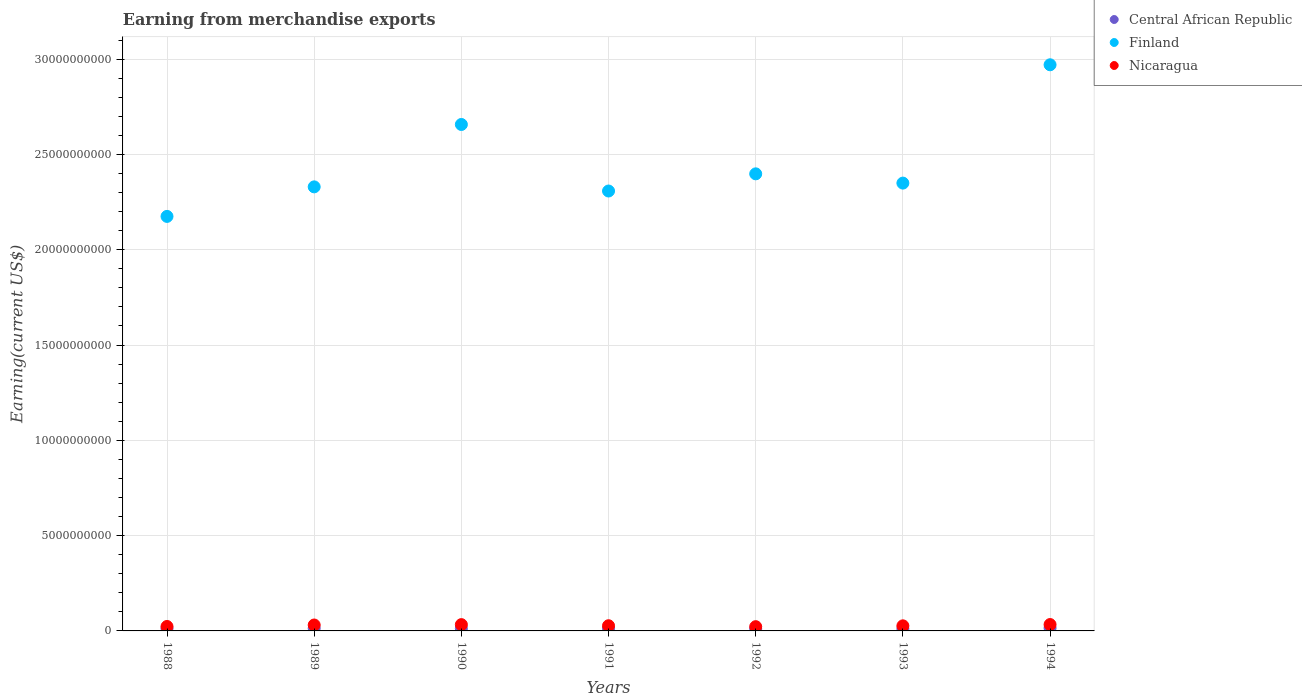How many different coloured dotlines are there?
Your response must be concise. 3. Is the number of dotlines equal to the number of legend labels?
Ensure brevity in your answer.  Yes. What is the amount earned from merchandise exports in Finland in 1988?
Ensure brevity in your answer.  2.17e+1. Across all years, what is the maximum amount earned from merchandise exports in Nicaragua?
Your answer should be very brief. 3.35e+08. Across all years, what is the minimum amount earned from merchandise exports in Central African Republic?
Your response must be concise. 1.07e+08. In which year was the amount earned from merchandise exports in Central African Republic maximum?
Provide a short and direct response. 1994. What is the total amount earned from merchandise exports in Nicaragua in the graph?
Give a very brief answer. 1.97e+09. What is the difference between the amount earned from merchandise exports in Nicaragua in 1988 and that in 1992?
Give a very brief answer. 1.00e+07. What is the difference between the amount earned from merchandise exports in Nicaragua in 1993 and the amount earned from merchandise exports in Finland in 1988?
Offer a very short reply. -2.15e+1. What is the average amount earned from merchandise exports in Central African Republic per year?
Your response must be concise. 1.25e+08. In the year 1993, what is the difference between the amount earned from merchandise exports in Central African Republic and amount earned from merchandise exports in Finland?
Ensure brevity in your answer.  -2.34e+1. What is the ratio of the amount earned from merchandise exports in Nicaragua in 1993 to that in 1994?
Your response must be concise. 0.8. What is the difference between the highest and the second highest amount earned from merchandise exports in Finland?
Provide a short and direct response. 3.13e+09. What is the difference between the highest and the lowest amount earned from merchandise exports in Nicaragua?
Ensure brevity in your answer.  1.12e+08. Is the sum of the amount earned from merchandise exports in Central African Republic in 1988 and 1989 greater than the maximum amount earned from merchandise exports in Finland across all years?
Your answer should be compact. No. Is it the case that in every year, the sum of the amount earned from merchandise exports in Finland and amount earned from merchandise exports in Central African Republic  is greater than the amount earned from merchandise exports in Nicaragua?
Your answer should be compact. Yes. Is the amount earned from merchandise exports in Central African Republic strictly greater than the amount earned from merchandise exports in Nicaragua over the years?
Offer a very short reply. No. How many dotlines are there?
Keep it short and to the point. 3. Does the graph contain any zero values?
Give a very brief answer. No. How many legend labels are there?
Ensure brevity in your answer.  3. What is the title of the graph?
Your answer should be very brief. Earning from merchandise exports. What is the label or title of the Y-axis?
Keep it short and to the point. Earning(current US$). What is the Earning(current US$) of Central African Republic in 1988?
Offer a very short reply. 1.30e+08. What is the Earning(current US$) of Finland in 1988?
Provide a succinct answer. 2.17e+1. What is the Earning(current US$) of Nicaragua in 1988?
Your answer should be compact. 2.33e+08. What is the Earning(current US$) of Central African Republic in 1989?
Ensure brevity in your answer.  1.34e+08. What is the Earning(current US$) of Finland in 1989?
Offer a very short reply. 2.33e+1. What is the Earning(current US$) in Nicaragua in 1989?
Your answer should be very brief. 3.11e+08. What is the Earning(current US$) in Central African Republic in 1990?
Your answer should be very brief. 1.20e+08. What is the Earning(current US$) in Finland in 1990?
Provide a succinct answer. 2.66e+1. What is the Earning(current US$) of Nicaragua in 1990?
Ensure brevity in your answer.  3.30e+08. What is the Earning(current US$) in Central African Republic in 1991?
Keep it short and to the point. 1.26e+08. What is the Earning(current US$) in Finland in 1991?
Keep it short and to the point. 2.31e+1. What is the Earning(current US$) of Nicaragua in 1991?
Your response must be concise. 2.72e+08. What is the Earning(current US$) of Central African Republic in 1992?
Provide a short and direct response. 1.07e+08. What is the Earning(current US$) of Finland in 1992?
Make the answer very short. 2.40e+1. What is the Earning(current US$) of Nicaragua in 1992?
Keep it short and to the point. 2.23e+08. What is the Earning(current US$) of Central African Republic in 1993?
Provide a succinct answer. 1.10e+08. What is the Earning(current US$) in Finland in 1993?
Make the answer very short. 2.35e+1. What is the Earning(current US$) of Nicaragua in 1993?
Your answer should be compact. 2.67e+08. What is the Earning(current US$) in Central African Republic in 1994?
Your response must be concise. 1.51e+08. What is the Earning(current US$) in Finland in 1994?
Ensure brevity in your answer.  2.97e+1. What is the Earning(current US$) in Nicaragua in 1994?
Your answer should be compact. 3.35e+08. Across all years, what is the maximum Earning(current US$) of Central African Republic?
Provide a short and direct response. 1.51e+08. Across all years, what is the maximum Earning(current US$) of Finland?
Your answer should be compact. 2.97e+1. Across all years, what is the maximum Earning(current US$) of Nicaragua?
Provide a short and direct response. 3.35e+08. Across all years, what is the minimum Earning(current US$) of Central African Republic?
Your answer should be compact. 1.07e+08. Across all years, what is the minimum Earning(current US$) of Finland?
Ensure brevity in your answer.  2.17e+1. Across all years, what is the minimum Earning(current US$) in Nicaragua?
Your response must be concise. 2.23e+08. What is the total Earning(current US$) of Central African Republic in the graph?
Ensure brevity in your answer.  8.78e+08. What is the total Earning(current US$) of Finland in the graph?
Your answer should be very brief. 1.72e+11. What is the total Earning(current US$) in Nicaragua in the graph?
Keep it short and to the point. 1.97e+09. What is the difference between the Earning(current US$) in Central African Republic in 1988 and that in 1989?
Offer a terse response. -4.00e+06. What is the difference between the Earning(current US$) in Finland in 1988 and that in 1989?
Offer a very short reply. -1.55e+09. What is the difference between the Earning(current US$) of Nicaragua in 1988 and that in 1989?
Make the answer very short. -7.80e+07. What is the difference between the Earning(current US$) of Central African Republic in 1988 and that in 1990?
Provide a short and direct response. 1.00e+07. What is the difference between the Earning(current US$) in Finland in 1988 and that in 1990?
Ensure brevity in your answer.  -4.82e+09. What is the difference between the Earning(current US$) of Nicaragua in 1988 and that in 1990?
Ensure brevity in your answer.  -9.70e+07. What is the difference between the Earning(current US$) in Central African Republic in 1988 and that in 1991?
Make the answer very short. 4.00e+06. What is the difference between the Earning(current US$) in Finland in 1988 and that in 1991?
Your answer should be compact. -1.33e+09. What is the difference between the Earning(current US$) of Nicaragua in 1988 and that in 1991?
Ensure brevity in your answer.  -3.90e+07. What is the difference between the Earning(current US$) of Central African Republic in 1988 and that in 1992?
Provide a short and direct response. 2.30e+07. What is the difference between the Earning(current US$) of Finland in 1988 and that in 1992?
Offer a terse response. -2.23e+09. What is the difference between the Earning(current US$) in Finland in 1988 and that in 1993?
Provide a short and direct response. -1.75e+09. What is the difference between the Earning(current US$) in Nicaragua in 1988 and that in 1993?
Provide a short and direct response. -3.40e+07. What is the difference between the Earning(current US$) in Central African Republic in 1988 and that in 1994?
Your answer should be compact. -2.10e+07. What is the difference between the Earning(current US$) of Finland in 1988 and that in 1994?
Ensure brevity in your answer.  -7.96e+09. What is the difference between the Earning(current US$) of Nicaragua in 1988 and that in 1994?
Offer a very short reply. -1.02e+08. What is the difference between the Earning(current US$) of Central African Republic in 1989 and that in 1990?
Your answer should be compact. 1.40e+07. What is the difference between the Earning(current US$) of Finland in 1989 and that in 1990?
Your answer should be very brief. -3.27e+09. What is the difference between the Earning(current US$) in Nicaragua in 1989 and that in 1990?
Offer a terse response. -1.90e+07. What is the difference between the Earning(current US$) of Central African Republic in 1989 and that in 1991?
Your answer should be compact. 8.00e+06. What is the difference between the Earning(current US$) of Finland in 1989 and that in 1991?
Your response must be concise. 2.18e+08. What is the difference between the Earning(current US$) of Nicaragua in 1989 and that in 1991?
Ensure brevity in your answer.  3.90e+07. What is the difference between the Earning(current US$) of Central African Republic in 1989 and that in 1992?
Provide a succinct answer. 2.70e+07. What is the difference between the Earning(current US$) in Finland in 1989 and that in 1992?
Your answer should be very brief. -6.83e+08. What is the difference between the Earning(current US$) of Nicaragua in 1989 and that in 1992?
Your answer should be very brief. 8.80e+07. What is the difference between the Earning(current US$) in Central African Republic in 1989 and that in 1993?
Ensure brevity in your answer.  2.40e+07. What is the difference between the Earning(current US$) in Finland in 1989 and that in 1993?
Your answer should be very brief. -1.97e+08. What is the difference between the Earning(current US$) of Nicaragua in 1989 and that in 1993?
Provide a short and direct response. 4.40e+07. What is the difference between the Earning(current US$) in Central African Republic in 1989 and that in 1994?
Your answer should be very brief. -1.70e+07. What is the difference between the Earning(current US$) in Finland in 1989 and that in 1994?
Give a very brief answer. -6.40e+09. What is the difference between the Earning(current US$) of Nicaragua in 1989 and that in 1994?
Provide a short and direct response. -2.37e+07. What is the difference between the Earning(current US$) of Central African Republic in 1990 and that in 1991?
Offer a terse response. -6.00e+06. What is the difference between the Earning(current US$) in Finland in 1990 and that in 1991?
Your answer should be very brief. 3.49e+09. What is the difference between the Earning(current US$) of Nicaragua in 1990 and that in 1991?
Provide a succinct answer. 5.80e+07. What is the difference between the Earning(current US$) of Central African Republic in 1990 and that in 1992?
Give a very brief answer. 1.30e+07. What is the difference between the Earning(current US$) of Finland in 1990 and that in 1992?
Your answer should be compact. 2.59e+09. What is the difference between the Earning(current US$) of Nicaragua in 1990 and that in 1992?
Make the answer very short. 1.07e+08. What is the difference between the Earning(current US$) in Finland in 1990 and that in 1993?
Make the answer very short. 3.08e+09. What is the difference between the Earning(current US$) of Nicaragua in 1990 and that in 1993?
Offer a very short reply. 6.30e+07. What is the difference between the Earning(current US$) in Central African Republic in 1990 and that in 1994?
Your response must be concise. -3.10e+07. What is the difference between the Earning(current US$) of Finland in 1990 and that in 1994?
Your answer should be compact. -3.13e+09. What is the difference between the Earning(current US$) of Nicaragua in 1990 and that in 1994?
Ensure brevity in your answer.  -4.70e+06. What is the difference between the Earning(current US$) in Central African Republic in 1991 and that in 1992?
Offer a terse response. 1.90e+07. What is the difference between the Earning(current US$) in Finland in 1991 and that in 1992?
Keep it short and to the point. -9.01e+08. What is the difference between the Earning(current US$) of Nicaragua in 1991 and that in 1992?
Ensure brevity in your answer.  4.90e+07. What is the difference between the Earning(current US$) of Central African Republic in 1991 and that in 1993?
Offer a very short reply. 1.60e+07. What is the difference between the Earning(current US$) in Finland in 1991 and that in 1993?
Offer a terse response. -4.15e+08. What is the difference between the Earning(current US$) of Central African Republic in 1991 and that in 1994?
Keep it short and to the point. -2.50e+07. What is the difference between the Earning(current US$) in Finland in 1991 and that in 1994?
Your response must be concise. -6.62e+09. What is the difference between the Earning(current US$) in Nicaragua in 1991 and that in 1994?
Provide a short and direct response. -6.27e+07. What is the difference between the Earning(current US$) in Central African Republic in 1992 and that in 1993?
Offer a very short reply. -3.00e+06. What is the difference between the Earning(current US$) of Finland in 1992 and that in 1993?
Keep it short and to the point. 4.86e+08. What is the difference between the Earning(current US$) in Nicaragua in 1992 and that in 1993?
Offer a terse response. -4.40e+07. What is the difference between the Earning(current US$) of Central African Republic in 1992 and that in 1994?
Make the answer very short. -4.40e+07. What is the difference between the Earning(current US$) of Finland in 1992 and that in 1994?
Keep it short and to the point. -5.72e+09. What is the difference between the Earning(current US$) in Nicaragua in 1992 and that in 1994?
Your answer should be compact. -1.12e+08. What is the difference between the Earning(current US$) of Central African Republic in 1993 and that in 1994?
Provide a short and direct response. -4.10e+07. What is the difference between the Earning(current US$) of Finland in 1993 and that in 1994?
Ensure brevity in your answer.  -6.21e+09. What is the difference between the Earning(current US$) in Nicaragua in 1993 and that in 1994?
Offer a very short reply. -6.77e+07. What is the difference between the Earning(current US$) of Central African Republic in 1988 and the Earning(current US$) of Finland in 1989?
Make the answer very short. -2.32e+1. What is the difference between the Earning(current US$) in Central African Republic in 1988 and the Earning(current US$) in Nicaragua in 1989?
Provide a succinct answer. -1.81e+08. What is the difference between the Earning(current US$) in Finland in 1988 and the Earning(current US$) in Nicaragua in 1989?
Your response must be concise. 2.14e+1. What is the difference between the Earning(current US$) in Central African Republic in 1988 and the Earning(current US$) in Finland in 1990?
Offer a very short reply. -2.64e+1. What is the difference between the Earning(current US$) in Central African Republic in 1988 and the Earning(current US$) in Nicaragua in 1990?
Offer a very short reply. -2.00e+08. What is the difference between the Earning(current US$) of Finland in 1988 and the Earning(current US$) of Nicaragua in 1990?
Offer a terse response. 2.14e+1. What is the difference between the Earning(current US$) in Central African Republic in 1988 and the Earning(current US$) in Finland in 1991?
Your answer should be compact. -2.30e+1. What is the difference between the Earning(current US$) of Central African Republic in 1988 and the Earning(current US$) of Nicaragua in 1991?
Ensure brevity in your answer.  -1.42e+08. What is the difference between the Earning(current US$) in Finland in 1988 and the Earning(current US$) in Nicaragua in 1991?
Provide a short and direct response. 2.15e+1. What is the difference between the Earning(current US$) in Central African Republic in 1988 and the Earning(current US$) in Finland in 1992?
Your response must be concise. -2.39e+1. What is the difference between the Earning(current US$) of Central African Republic in 1988 and the Earning(current US$) of Nicaragua in 1992?
Keep it short and to the point. -9.30e+07. What is the difference between the Earning(current US$) in Finland in 1988 and the Earning(current US$) in Nicaragua in 1992?
Ensure brevity in your answer.  2.15e+1. What is the difference between the Earning(current US$) of Central African Republic in 1988 and the Earning(current US$) of Finland in 1993?
Your answer should be compact. -2.34e+1. What is the difference between the Earning(current US$) in Central African Republic in 1988 and the Earning(current US$) in Nicaragua in 1993?
Offer a very short reply. -1.37e+08. What is the difference between the Earning(current US$) of Finland in 1988 and the Earning(current US$) of Nicaragua in 1993?
Make the answer very short. 2.15e+1. What is the difference between the Earning(current US$) in Central African Republic in 1988 and the Earning(current US$) in Finland in 1994?
Ensure brevity in your answer.  -2.96e+1. What is the difference between the Earning(current US$) in Central African Republic in 1988 and the Earning(current US$) in Nicaragua in 1994?
Offer a very short reply. -2.05e+08. What is the difference between the Earning(current US$) of Finland in 1988 and the Earning(current US$) of Nicaragua in 1994?
Ensure brevity in your answer.  2.14e+1. What is the difference between the Earning(current US$) in Central African Republic in 1989 and the Earning(current US$) in Finland in 1990?
Provide a short and direct response. -2.64e+1. What is the difference between the Earning(current US$) in Central African Republic in 1989 and the Earning(current US$) in Nicaragua in 1990?
Offer a terse response. -1.96e+08. What is the difference between the Earning(current US$) of Finland in 1989 and the Earning(current US$) of Nicaragua in 1990?
Your answer should be very brief. 2.30e+1. What is the difference between the Earning(current US$) in Central African Republic in 1989 and the Earning(current US$) in Finland in 1991?
Your answer should be very brief. -2.29e+1. What is the difference between the Earning(current US$) of Central African Republic in 1989 and the Earning(current US$) of Nicaragua in 1991?
Offer a terse response. -1.38e+08. What is the difference between the Earning(current US$) of Finland in 1989 and the Earning(current US$) of Nicaragua in 1991?
Your answer should be very brief. 2.30e+1. What is the difference between the Earning(current US$) of Central African Republic in 1989 and the Earning(current US$) of Finland in 1992?
Give a very brief answer. -2.38e+1. What is the difference between the Earning(current US$) of Central African Republic in 1989 and the Earning(current US$) of Nicaragua in 1992?
Provide a short and direct response. -8.90e+07. What is the difference between the Earning(current US$) of Finland in 1989 and the Earning(current US$) of Nicaragua in 1992?
Make the answer very short. 2.31e+1. What is the difference between the Earning(current US$) of Central African Republic in 1989 and the Earning(current US$) of Finland in 1993?
Provide a short and direct response. -2.34e+1. What is the difference between the Earning(current US$) of Central African Republic in 1989 and the Earning(current US$) of Nicaragua in 1993?
Ensure brevity in your answer.  -1.33e+08. What is the difference between the Earning(current US$) of Finland in 1989 and the Earning(current US$) of Nicaragua in 1993?
Give a very brief answer. 2.30e+1. What is the difference between the Earning(current US$) of Central African Republic in 1989 and the Earning(current US$) of Finland in 1994?
Your answer should be very brief. -2.96e+1. What is the difference between the Earning(current US$) in Central African Republic in 1989 and the Earning(current US$) in Nicaragua in 1994?
Your answer should be compact. -2.01e+08. What is the difference between the Earning(current US$) of Finland in 1989 and the Earning(current US$) of Nicaragua in 1994?
Offer a terse response. 2.30e+1. What is the difference between the Earning(current US$) in Central African Republic in 1990 and the Earning(current US$) in Finland in 1991?
Provide a succinct answer. -2.30e+1. What is the difference between the Earning(current US$) in Central African Republic in 1990 and the Earning(current US$) in Nicaragua in 1991?
Your answer should be compact. -1.52e+08. What is the difference between the Earning(current US$) of Finland in 1990 and the Earning(current US$) of Nicaragua in 1991?
Ensure brevity in your answer.  2.63e+1. What is the difference between the Earning(current US$) in Central African Republic in 1990 and the Earning(current US$) in Finland in 1992?
Keep it short and to the point. -2.39e+1. What is the difference between the Earning(current US$) in Central African Republic in 1990 and the Earning(current US$) in Nicaragua in 1992?
Offer a terse response. -1.03e+08. What is the difference between the Earning(current US$) in Finland in 1990 and the Earning(current US$) in Nicaragua in 1992?
Offer a very short reply. 2.63e+1. What is the difference between the Earning(current US$) of Central African Republic in 1990 and the Earning(current US$) of Finland in 1993?
Your answer should be very brief. -2.34e+1. What is the difference between the Earning(current US$) in Central African Republic in 1990 and the Earning(current US$) in Nicaragua in 1993?
Your answer should be very brief. -1.47e+08. What is the difference between the Earning(current US$) of Finland in 1990 and the Earning(current US$) of Nicaragua in 1993?
Keep it short and to the point. 2.63e+1. What is the difference between the Earning(current US$) of Central African Republic in 1990 and the Earning(current US$) of Finland in 1994?
Ensure brevity in your answer.  -2.96e+1. What is the difference between the Earning(current US$) in Central African Republic in 1990 and the Earning(current US$) in Nicaragua in 1994?
Offer a terse response. -2.15e+08. What is the difference between the Earning(current US$) of Finland in 1990 and the Earning(current US$) of Nicaragua in 1994?
Give a very brief answer. 2.62e+1. What is the difference between the Earning(current US$) of Central African Republic in 1991 and the Earning(current US$) of Finland in 1992?
Provide a succinct answer. -2.39e+1. What is the difference between the Earning(current US$) in Central African Republic in 1991 and the Earning(current US$) in Nicaragua in 1992?
Provide a short and direct response. -9.70e+07. What is the difference between the Earning(current US$) of Finland in 1991 and the Earning(current US$) of Nicaragua in 1992?
Make the answer very short. 2.29e+1. What is the difference between the Earning(current US$) of Central African Republic in 1991 and the Earning(current US$) of Finland in 1993?
Provide a succinct answer. -2.34e+1. What is the difference between the Earning(current US$) in Central African Republic in 1991 and the Earning(current US$) in Nicaragua in 1993?
Ensure brevity in your answer.  -1.41e+08. What is the difference between the Earning(current US$) in Finland in 1991 and the Earning(current US$) in Nicaragua in 1993?
Provide a succinct answer. 2.28e+1. What is the difference between the Earning(current US$) of Central African Republic in 1991 and the Earning(current US$) of Finland in 1994?
Give a very brief answer. -2.96e+1. What is the difference between the Earning(current US$) of Central African Republic in 1991 and the Earning(current US$) of Nicaragua in 1994?
Your response must be concise. -2.09e+08. What is the difference between the Earning(current US$) of Finland in 1991 and the Earning(current US$) of Nicaragua in 1994?
Your answer should be very brief. 2.27e+1. What is the difference between the Earning(current US$) of Central African Republic in 1992 and the Earning(current US$) of Finland in 1993?
Ensure brevity in your answer.  -2.34e+1. What is the difference between the Earning(current US$) in Central African Republic in 1992 and the Earning(current US$) in Nicaragua in 1993?
Keep it short and to the point. -1.60e+08. What is the difference between the Earning(current US$) in Finland in 1992 and the Earning(current US$) in Nicaragua in 1993?
Keep it short and to the point. 2.37e+1. What is the difference between the Earning(current US$) of Central African Republic in 1992 and the Earning(current US$) of Finland in 1994?
Your response must be concise. -2.96e+1. What is the difference between the Earning(current US$) of Central African Republic in 1992 and the Earning(current US$) of Nicaragua in 1994?
Offer a terse response. -2.28e+08. What is the difference between the Earning(current US$) of Finland in 1992 and the Earning(current US$) of Nicaragua in 1994?
Offer a terse response. 2.36e+1. What is the difference between the Earning(current US$) in Central African Republic in 1993 and the Earning(current US$) in Finland in 1994?
Make the answer very short. -2.96e+1. What is the difference between the Earning(current US$) in Central African Republic in 1993 and the Earning(current US$) in Nicaragua in 1994?
Provide a short and direct response. -2.25e+08. What is the difference between the Earning(current US$) in Finland in 1993 and the Earning(current US$) in Nicaragua in 1994?
Offer a terse response. 2.32e+1. What is the average Earning(current US$) in Central African Republic per year?
Your answer should be compact. 1.25e+08. What is the average Earning(current US$) in Finland per year?
Your response must be concise. 2.46e+1. What is the average Earning(current US$) in Nicaragua per year?
Offer a very short reply. 2.82e+08. In the year 1988, what is the difference between the Earning(current US$) of Central African Republic and Earning(current US$) of Finland?
Your response must be concise. -2.16e+1. In the year 1988, what is the difference between the Earning(current US$) in Central African Republic and Earning(current US$) in Nicaragua?
Offer a very short reply. -1.03e+08. In the year 1988, what is the difference between the Earning(current US$) of Finland and Earning(current US$) of Nicaragua?
Your response must be concise. 2.15e+1. In the year 1989, what is the difference between the Earning(current US$) in Central African Republic and Earning(current US$) in Finland?
Offer a very short reply. -2.32e+1. In the year 1989, what is the difference between the Earning(current US$) of Central African Republic and Earning(current US$) of Nicaragua?
Provide a succinct answer. -1.77e+08. In the year 1989, what is the difference between the Earning(current US$) in Finland and Earning(current US$) in Nicaragua?
Offer a very short reply. 2.30e+1. In the year 1990, what is the difference between the Earning(current US$) in Central African Republic and Earning(current US$) in Finland?
Ensure brevity in your answer.  -2.65e+1. In the year 1990, what is the difference between the Earning(current US$) of Central African Republic and Earning(current US$) of Nicaragua?
Provide a succinct answer. -2.10e+08. In the year 1990, what is the difference between the Earning(current US$) of Finland and Earning(current US$) of Nicaragua?
Give a very brief answer. 2.62e+1. In the year 1991, what is the difference between the Earning(current US$) in Central African Republic and Earning(current US$) in Finland?
Your response must be concise. -2.30e+1. In the year 1991, what is the difference between the Earning(current US$) in Central African Republic and Earning(current US$) in Nicaragua?
Your answer should be compact. -1.46e+08. In the year 1991, what is the difference between the Earning(current US$) of Finland and Earning(current US$) of Nicaragua?
Your answer should be very brief. 2.28e+1. In the year 1992, what is the difference between the Earning(current US$) of Central African Republic and Earning(current US$) of Finland?
Your response must be concise. -2.39e+1. In the year 1992, what is the difference between the Earning(current US$) in Central African Republic and Earning(current US$) in Nicaragua?
Your answer should be very brief. -1.16e+08. In the year 1992, what is the difference between the Earning(current US$) of Finland and Earning(current US$) of Nicaragua?
Your answer should be very brief. 2.38e+1. In the year 1993, what is the difference between the Earning(current US$) in Central African Republic and Earning(current US$) in Finland?
Ensure brevity in your answer.  -2.34e+1. In the year 1993, what is the difference between the Earning(current US$) in Central African Republic and Earning(current US$) in Nicaragua?
Offer a terse response. -1.57e+08. In the year 1993, what is the difference between the Earning(current US$) of Finland and Earning(current US$) of Nicaragua?
Give a very brief answer. 2.32e+1. In the year 1994, what is the difference between the Earning(current US$) of Central African Republic and Earning(current US$) of Finland?
Make the answer very short. -2.96e+1. In the year 1994, what is the difference between the Earning(current US$) in Central African Republic and Earning(current US$) in Nicaragua?
Your answer should be very brief. -1.84e+08. In the year 1994, what is the difference between the Earning(current US$) in Finland and Earning(current US$) in Nicaragua?
Ensure brevity in your answer.  2.94e+1. What is the ratio of the Earning(current US$) in Central African Republic in 1988 to that in 1989?
Your answer should be very brief. 0.97. What is the ratio of the Earning(current US$) of Finland in 1988 to that in 1989?
Offer a terse response. 0.93. What is the ratio of the Earning(current US$) in Nicaragua in 1988 to that in 1989?
Ensure brevity in your answer.  0.75. What is the ratio of the Earning(current US$) in Finland in 1988 to that in 1990?
Keep it short and to the point. 0.82. What is the ratio of the Earning(current US$) in Nicaragua in 1988 to that in 1990?
Ensure brevity in your answer.  0.71. What is the ratio of the Earning(current US$) in Central African Republic in 1988 to that in 1991?
Offer a terse response. 1.03. What is the ratio of the Earning(current US$) of Finland in 1988 to that in 1991?
Give a very brief answer. 0.94. What is the ratio of the Earning(current US$) of Nicaragua in 1988 to that in 1991?
Your answer should be compact. 0.86. What is the ratio of the Earning(current US$) in Central African Republic in 1988 to that in 1992?
Give a very brief answer. 1.22. What is the ratio of the Earning(current US$) in Finland in 1988 to that in 1992?
Ensure brevity in your answer.  0.91. What is the ratio of the Earning(current US$) in Nicaragua in 1988 to that in 1992?
Ensure brevity in your answer.  1.04. What is the ratio of the Earning(current US$) of Central African Republic in 1988 to that in 1993?
Provide a short and direct response. 1.18. What is the ratio of the Earning(current US$) of Finland in 1988 to that in 1993?
Offer a very short reply. 0.93. What is the ratio of the Earning(current US$) of Nicaragua in 1988 to that in 1993?
Give a very brief answer. 0.87. What is the ratio of the Earning(current US$) of Central African Republic in 1988 to that in 1994?
Provide a succinct answer. 0.86. What is the ratio of the Earning(current US$) of Finland in 1988 to that in 1994?
Ensure brevity in your answer.  0.73. What is the ratio of the Earning(current US$) of Nicaragua in 1988 to that in 1994?
Your response must be concise. 0.7. What is the ratio of the Earning(current US$) of Central African Republic in 1989 to that in 1990?
Your answer should be very brief. 1.12. What is the ratio of the Earning(current US$) of Finland in 1989 to that in 1990?
Offer a very short reply. 0.88. What is the ratio of the Earning(current US$) of Nicaragua in 1989 to that in 1990?
Ensure brevity in your answer.  0.94. What is the ratio of the Earning(current US$) in Central African Republic in 1989 to that in 1991?
Make the answer very short. 1.06. What is the ratio of the Earning(current US$) in Finland in 1989 to that in 1991?
Your answer should be very brief. 1.01. What is the ratio of the Earning(current US$) of Nicaragua in 1989 to that in 1991?
Provide a succinct answer. 1.14. What is the ratio of the Earning(current US$) in Central African Republic in 1989 to that in 1992?
Your response must be concise. 1.25. What is the ratio of the Earning(current US$) in Finland in 1989 to that in 1992?
Keep it short and to the point. 0.97. What is the ratio of the Earning(current US$) of Nicaragua in 1989 to that in 1992?
Offer a terse response. 1.39. What is the ratio of the Earning(current US$) of Central African Republic in 1989 to that in 1993?
Give a very brief answer. 1.22. What is the ratio of the Earning(current US$) of Nicaragua in 1989 to that in 1993?
Offer a very short reply. 1.16. What is the ratio of the Earning(current US$) of Central African Republic in 1989 to that in 1994?
Provide a short and direct response. 0.89. What is the ratio of the Earning(current US$) in Finland in 1989 to that in 1994?
Provide a succinct answer. 0.78. What is the ratio of the Earning(current US$) in Nicaragua in 1989 to that in 1994?
Provide a short and direct response. 0.93. What is the ratio of the Earning(current US$) of Finland in 1990 to that in 1991?
Make the answer very short. 1.15. What is the ratio of the Earning(current US$) in Nicaragua in 1990 to that in 1991?
Ensure brevity in your answer.  1.21. What is the ratio of the Earning(current US$) in Central African Republic in 1990 to that in 1992?
Offer a very short reply. 1.12. What is the ratio of the Earning(current US$) in Finland in 1990 to that in 1992?
Give a very brief answer. 1.11. What is the ratio of the Earning(current US$) of Nicaragua in 1990 to that in 1992?
Your answer should be very brief. 1.48. What is the ratio of the Earning(current US$) in Central African Republic in 1990 to that in 1993?
Provide a short and direct response. 1.09. What is the ratio of the Earning(current US$) in Finland in 1990 to that in 1993?
Keep it short and to the point. 1.13. What is the ratio of the Earning(current US$) of Nicaragua in 1990 to that in 1993?
Make the answer very short. 1.24. What is the ratio of the Earning(current US$) in Central African Republic in 1990 to that in 1994?
Make the answer very short. 0.79. What is the ratio of the Earning(current US$) in Finland in 1990 to that in 1994?
Offer a very short reply. 0.89. What is the ratio of the Earning(current US$) in Nicaragua in 1990 to that in 1994?
Make the answer very short. 0.99. What is the ratio of the Earning(current US$) in Central African Republic in 1991 to that in 1992?
Your answer should be very brief. 1.18. What is the ratio of the Earning(current US$) in Finland in 1991 to that in 1992?
Your answer should be compact. 0.96. What is the ratio of the Earning(current US$) in Nicaragua in 1991 to that in 1992?
Ensure brevity in your answer.  1.22. What is the ratio of the Earning(current US$) of Central African Republic in 1991 to that in 1993?
Keep it short and to the point. 1.15. What is the ratio of the Earning(current US$) in Finland in 1991 to that in 1993?
Provide a succinct answer. 0.98. What is the ratio of the Earning(current US$) in Nicaragua in 1991 to that in 1993?
Give a very brief answer. 1.02. What is the ratio of the Earning(current US$) in Central African Republic in 1991 to that in 1994?
Your answer should be very brief. 0.83. What is the ratio of the Earning(current US$) in Finland in 1991 to that in 1994?
Ensure brevity in your answer.  0.78. What is the ratio of the Earning(current US$) in Nicaragua in 1991 to that in 1994?
Your response must be concise. 0.81. What is the ratio of the Earning(current US$) of Central African Republic in 1992 to that in 1993?
Keep it short and to the point. 0.97. What is the ratio of the Earning(current US$) in Finland in 1992 to that in 1993?
Your answer should be compact. 1.02. What is the ratio of the Earning(current US$) in Nicaragua in 1992 to that in 1993?
Provide a succinct answer. 0.84. What is the ratio of the Earning(current US$) of Central African Republic in 1992 to that in 1994?
Ensure brevity in your answer.  0.71. What is the ratio of the Earning(current US$) in Finland in 1992 to that in 1994?
Your response must be concise. 0.81. What is the ratio of the Earning(current US$) of Nicaragua in 1992 to that in 1994?
Provide a succinct answer. 0.67. What is the ratio of the Earning(current US$) of Central African Republic in 1993 to that in 1994?
Your response must be concise. 0.73. What is the ratio of the Earning(current US$) of Finland in 1993 to that in 1994?
Offer a very short reply. 0.79. What is the ratio of the Earning(current US$) in Nicaragua in 1993 to that in 1994?
Give a very brief answer. 0.8. What is the difference between the highest and the second highest Earning(current US$) in Central African Republic?
Make the answer very short. 1.70e+07. What is the difference between the highest and the second highest Earning(current US$) of Finland?
Ensure brevity in your answer.  3.13e+09. What is the difference between the highest and the second highest Earning(current US$) in Nicaragua?
Give a very brief answer. 4.70e+06. What is the difference between the highest and the lowest Earning(current US$) in Central African Republic?
Your answer should be very brief. 4.40e+07. What is the difference between the highest and the lowest Earning(current US$) in Finland?
Offer a very short reply. 7.96e+09. What is the difference between the highest and the lowest Earning(current US$) of Nicaragua?
Offer a very short reply. 1.12e+08. 